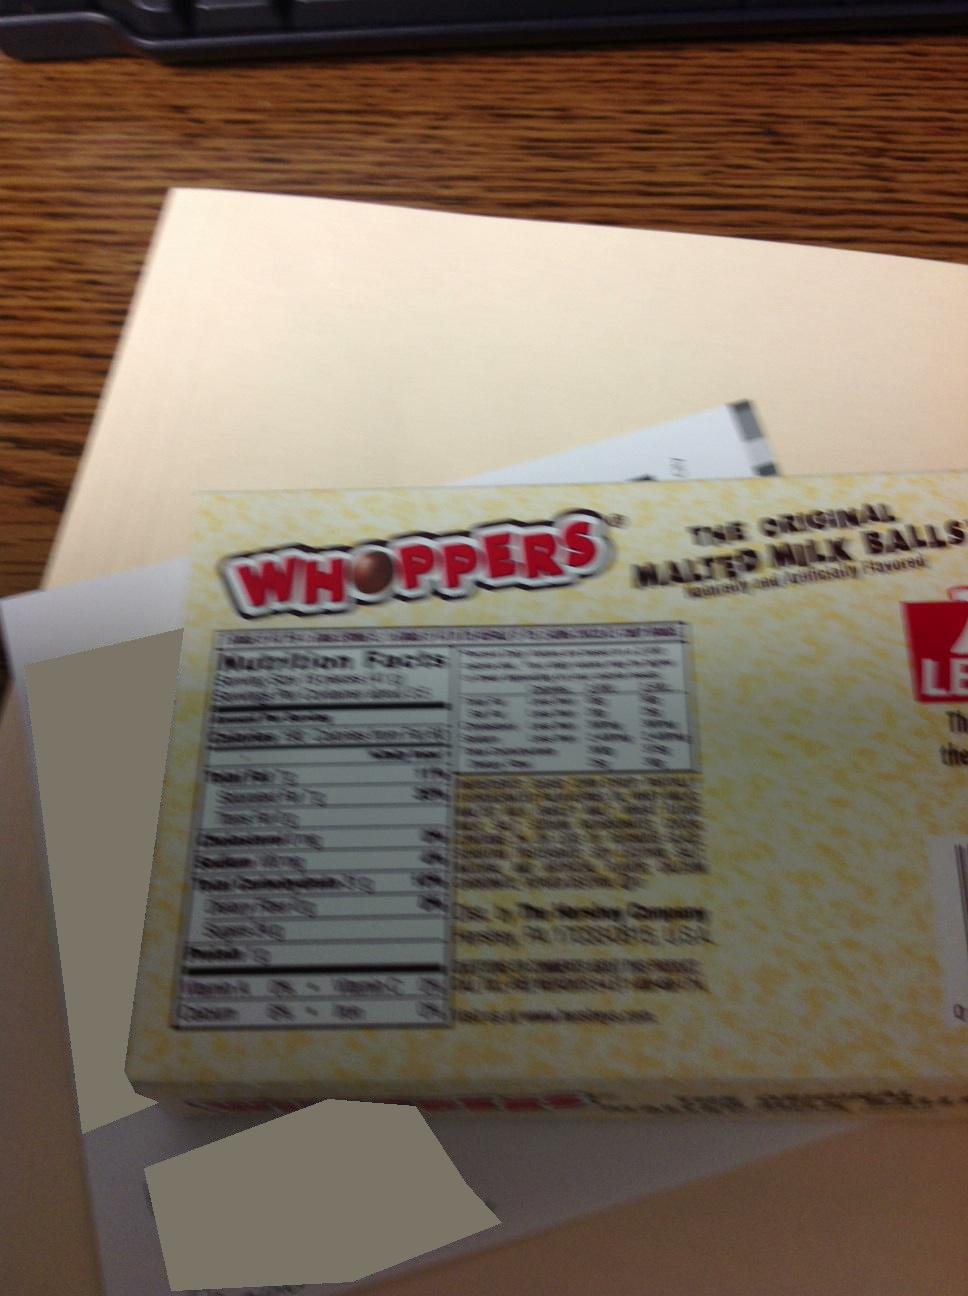Are there any nutritional details visible on the box? Yes, the packaging shows nutritional facts, including serving size, calories, and other nutrient information. What is the serving size and how many calories per serving? The serving size is 41 grams, amounting to 180 calories per serving. 